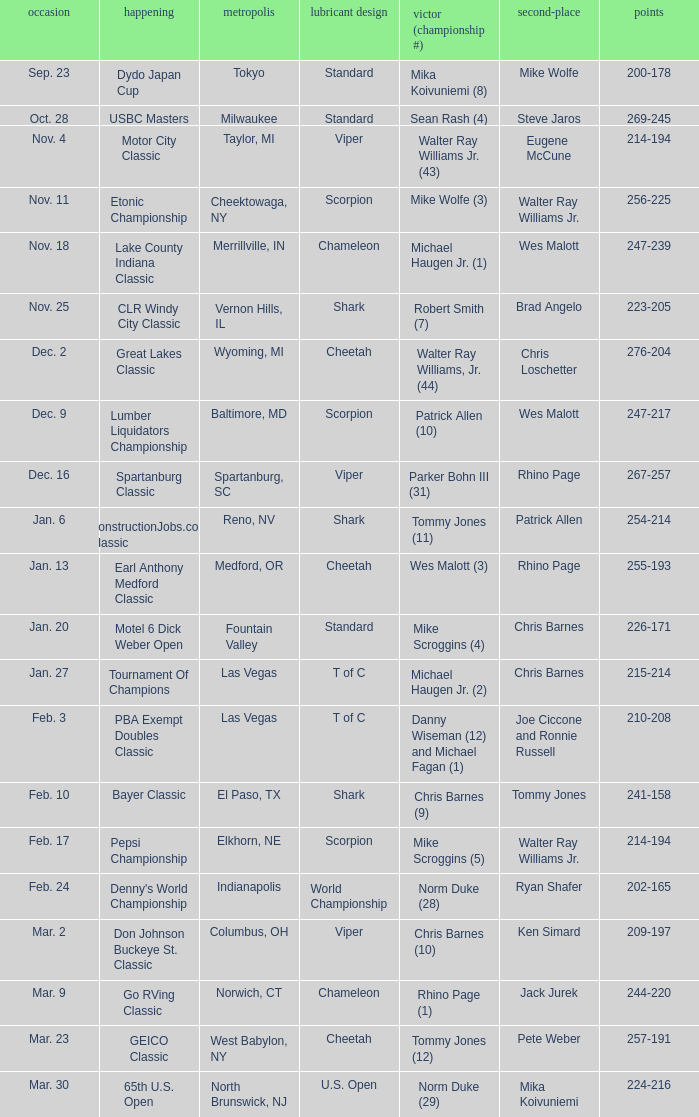Name the Date when has  robert smith (7)? Nov. 25. 